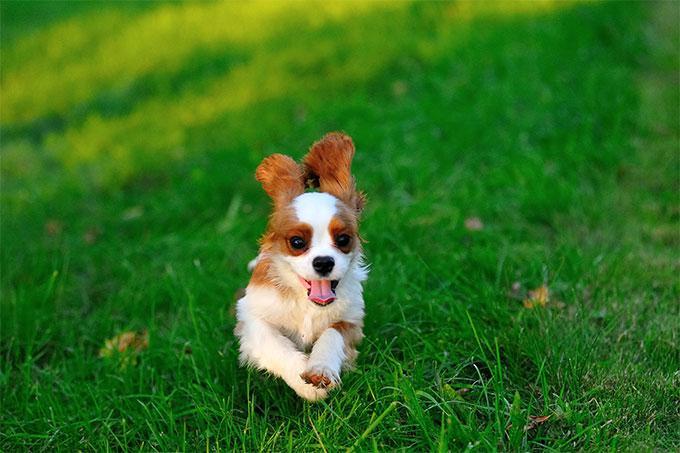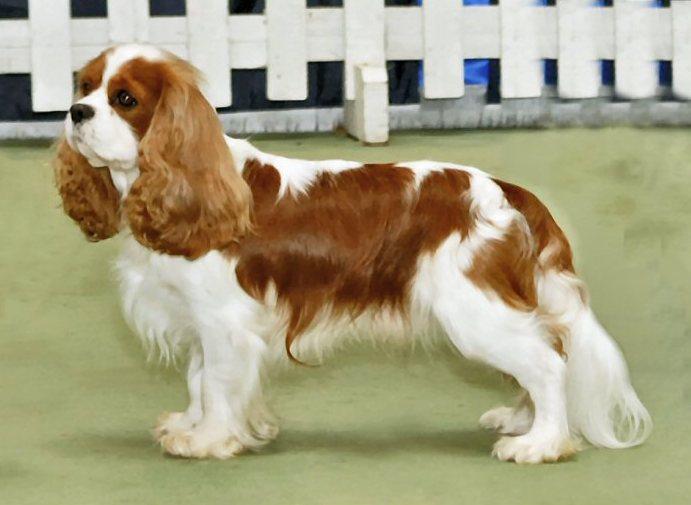The first image is the image on the left, the second image is the image on the right. Given the left and right images, does the statement "One image depicts exactly two dogs side by side on grass." hold true? Answer yes or no. No. 